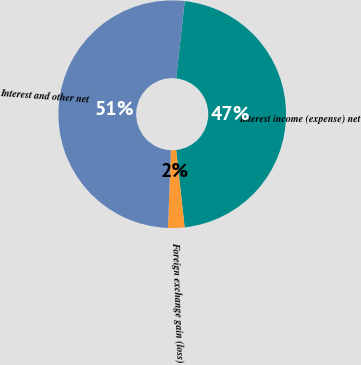Convert chart to OTSL. <chart><loc_0><loc_0><loc_500><loc_500><pie_chart><fcel>Interest income (expense) net<fcel>Foreign exchange gain (loss)<fcel>Interest and other net<nl><fcel>46.51%<fcel>2.33%<fcel>51.16%<nl></chart> 